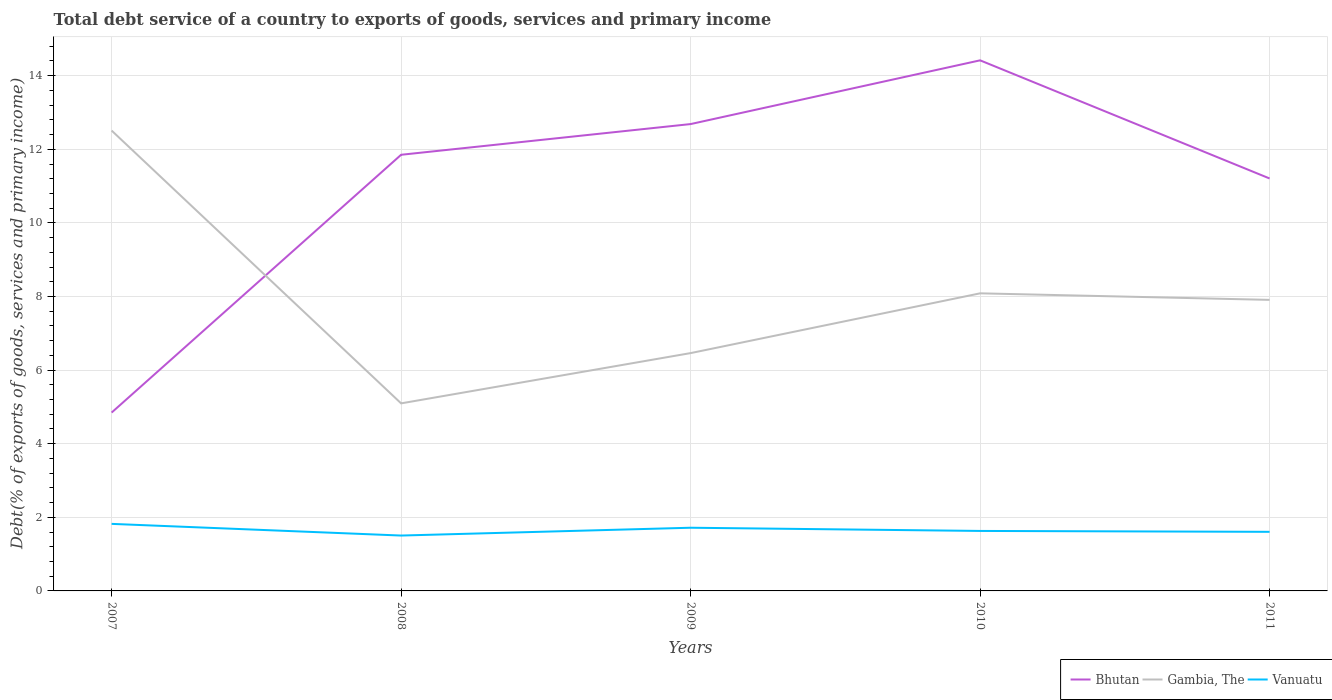How many different coloured lines are there?
Keep it short and to the point. 3. Across all years, what is the maximum total debt service in Gambia, The?
Your answer should be very brief. 5.1. In which year was the total debt service in Bhutan maximum?
Your answer should be very brief. 2007. What is the total total debt service in Bhutan in the graph?
Give a very brief answer. -7. What is the difference between the highest and the second highest total debt service in Gambia, The?
Your response must be concise. 7.41. What is the difference between the highest and the lowest total debt service in Gambia, The?
Make the answer very short. 2. Is the total debt service in Bhutan strictly greater than the total debt service in Gambia, The over the years?
Offer a very short reply. No. How many lines are there?
Provide a short and direct response. 3. How many years are there in the graph?
Provide a short and direct response. 5. Does the graph contain any zero values?
Offer a very short reply. No. Where does the legend appear in the graph?
Your answer should be compact. Bottom right. How many legend labels are there?
Provide a short and direct response. 3. What is the title of the graph?
Ensure brevity in your answer.  Total debt service of a country to exports of goods, services and primary income. What is the label or title of the Y-axis?
Your answer should be very brief. Debt(% of exports of goods, services and primary income). What is the Debt(% of exports of goods, services and primary income) of Bhutan in 2007?
Give a very brief answer. 4.85. What is the Debt(% of exports of goods, services and primary income) in Gambia, The in 2007?
Offer a terse response. 12.51. What is the Debt(% of exports of goods, services and primary income) in Vanuatu in 2007?
Provide a succinct answer. 1.82. What is the Debt(% of exports of goods, services and primary income) of Bhutan in 2008?
Your response must be concise. 11.85. What is the Debt(% of exports of goods, services and primary income) of Gambia, The in 2008?
Make the answer very short. 5.1. What is the Debt(% of exports of goods, services and primary income) of Vanuatu in 2008?
Provide a short and direct response. 1.5. What is the Debt(% of exports of goods, services and primary income) of Bhutan in 2009?
Offer a terse response. 12.68. What is the Debt(% of exports of goods, services and primary income) of Gambia, The in 2009?
Offer a terse response. 6.46. What is the Debt(% of exports of goods, services and primary income) of Vanuatu in 2009?
Your answer should be very brief. 1.72. What is the Debt(% of exports of goods, services and primary income) in Bhutan in 2010?
Give a very brief answer. 14.42. What is the Debt(% of exports of goods, services and primary income) of Gambia, The in 2010?
Ensure brevity in your answer.  8.09. What is the Debt(% of exports of goods, services and primary income) in Vanuatu in 2010?
Offer a very short reply. 1.63. What is the Debt(% of exports of goods, services and primary income) of Bhutan in 2011?
Give a very brief answer. 11.21. What is the Debt(% of exports of goods, services and primary income) in Gambia, The in 2011?
Make the answer very short. 7.91. What is the Debt(% of exports of goods, services and primary income) of Vanuatu in 2011?
Keep it short and to the point. 1.61. Across all years, what is the maximum Debt(% of exports of goods, services and primary income) of Bhutan?
Provide a succinct answer. 14.42. Across all years, what is the maximum Debt(% of exports of goods, services and primary income) of Gambia, The?
Offer a terse response. 12.51. Across all years, what is the maximum Debt(% of exports of goods, services and primary income) of Vanuatu?
Ensure brevity in your answer.  1.82. Across all years, what is the minimum Debt(% of exports of goods, services and primary income) in Bhutan?
Keep it short and to the point. 4.85. Across all years, what is the minimum Debt(% of exports of goods, services and primary income) in Gambia, The?
Your answer should be compact. 5.1. Across all years, what is the minimum Debt(% of exports of goods, services and primary income) in Vanuatu?
Make the answer very short. 1.5. What is the total Debt(% of exports of goods, services and primary income) in Bhutan in the graph?
Offer a terse response. 55.01. What is the total Debt(% of exports of goods, services and primary income) of Gambia, The in the graph?
Provide a succinct answer. 40.06. What is the total Debt(% of exports of goods, services and primary income) in Vanuatu in the graph?
Offer a very short reply. 8.28. What is the difference between the Debt(% of exports of goods, services and primary income) of Bhutan in 2007 and that in 2008?
Offer a very short reply. -7. What is the difference between the Debt(% of exports of goods, services and primary income) of Gambia, The in 2007 and that in 2008?
Provide a short and direct response. 7.41. What is the difference between the Debt(% of exports of goods, services and primary income) in Vanuatu in 2007 and that in 2008?
Your answer should be compact. 0.32. What is the difference between the Debt(% of exports of goods, services and primary income) of Bhutan in 2007 and that in 2009?
Give a very brief answer. -7.84. What is the difference between the Debt(% of exports of goods, services and primary income) in Gambia, The in 2007 and that in 2009?
Provide a succinct answer. 6.05. What is the difference between the Debt(% of exports of goods, services and primary income) of Vanuatu in 2007 and that in 2009?
Make the answer very short. 0.1. What is the difference between the Debt(% of exports of goods, services and primary income) in Bhutan in 2007 and that in 2010?
Give a very brief answer. -9.57. What is the difference between the Debt(% of exports of goods, services and primary income) of Gambia, The in 2007 and that in 2010?
Offer a very short reply. 4.42. What is the difference between the Debt(% of exports of goods, services and primary income) of Vanuatu in 2007 and that in 2010?
Give a very brief answer. 0.19. What is the difference between the Debt(% of exports of goods, services and primary income) of Bhutan in 2007 and that in 2011?
Keep it short and to the point. -6.36. What is the difference between the Debt(% of exports of goods, services and primary income) of Gambia, The in 2007 and that in 2011?
Offer a very short reply. 4.6. What is the difference between the Debt(% of exports of goods, services and primary income) of Vanuatu in 2007 and that in 2011?
Give a very brief answer. 0.22. What is the difference between the Debt(% of exports of goods, services and primary income) of Bhutan in 2008 and that in 2009?
Ensure brevity in your answer.  -0.83. What is the difference between the Debt(% of exports of goods, services and primary income) of Gambia, The in 2008 and that in 2009?
Offer a very short reply. -1.37. What is the difference between the Debt(% of exports of goods, services and primary income) of Vanuatu in 2008 and that in 2009?
Your answer should be very brief. -0.21. What is the difference between the Debt(% of exports of goods, services and primary income) in Bhutan in 2008 and that in 2010?
Provide a short and direct response. -2.57. What is the difference between the Debt(% of exports of goods, services and primary income) of Gambia, The in 2008 and that in 2010?
Your answer should be compact. -2.99. What is the difference between the Debt(% of exports of goods, services and primary income) in Vanuatu in 2008 and that in 2010?
Ensure brevity in your answer.  -0.13. What is the difference between the Debt(% of exports of goods, services and primary income) in Bhutan in 2008 and that in 2011?
Your answer should be compact. 0.64. What is the difference between the Debt(% of exports of goods, services and primary income) of Gambia, The in 2008 and that in 2011?
Make the answer very short. -2.81. What is the difference between the Debt(% of exports of goods, services and primary income) in Vanuatu in 2008 and that in 2011?
Your response must be concise. -0.1. What is the difference between the Debt(% of exports of goods, services and primary income) of Bhutan in 2009 and that in 2010?
Your response must be concise. -1.73. What is the difference between the Debt(% of exports of goods, services and primary income) in Gambia, The in 2009 and that in 2010?
Offer a very short reply. -1.62. What is the difference between the Debt(% of exports of goods, services and primary income) in Vanuatu in 2009 and that in 2010?
Your answer should be very brief. 0.09. What is the difference between the Debt(% of exports of goods, services and primary income) in Bhutan in 2009 and that in 2011?
Your answer should be compact. 1.48. What is the difference between the Debt(% of exports of goods, services and primary income) of Gambia, The in 2009 and that in 2011?
Offer a terse response. -1.45. What is the difference between the Debt(% of exports of goods, services and primary income) in Vanuatu in 2009 and that in 2011?
Offer a terse response. 0.11. What is the difference between the Debt(% of exports of goods, services and primary income) in Bhutan in 2010 and that in 2011?
Your answer should be very brief. 3.21. What is the difference between the Debt(% of exports of goods, services and primary income) in Gambia, The in 2010 and that in 2011?
Keep it short and to the point. 0.18. What is the difference between the Debt(% of exports of goods, services and primary income) of Vanuatu in 2010 and that in 2011?
Ensure brevity in your answer.  0.02. What is the difference between the Debt(% of exports of goods, services and primary income) in Bhutan in 2007 and the Debt(% of exports of goods, services and primary income) in Gambia, The in 2008?
Provide a short and direct response. -0.25. What is the difference between the Debt(% of exports of goods, services and primary income) in Bhutan in 2007 and the Debt(% of exports of goods, services and primary income) in Vanuatu in 2008?
Ensure brevity in your answer.  3.34. What is the difference between the Debt(% of exports of goods, services and primary income) in Gambia, The in 2007 and the Debt(% of exports of goods, services and primary income) in Vanuatu in 2008?
Keep it short and to the point. 11. What is the difference between the Debt(% of exports of goods, services and primary income) in Bhutan in 2007 and the Debt(% of exports of goods, services and primary income) in Gambia, The in 2009?
Offer a terse response. -1.62. What is the difference between the Debt(% of exports of goods, services and primary income) of Bhutan in 2007 and the Debt(% of exports of goods, services and primary income) of Vanuatu in 2009?
Your answer should be very brief. 3.13. What is the difference between the Debt(% of exports of goods, services and primary income) of Gambia, The in 2007 and the Debt(% of exports of goods, services and primary income) of Vanuatu in 2009?
Your answer should be compact. 10.79. What is the difference between the Debt(% of exports of goods, services and primary income) in Bhutan in 2007 and the Debt(% of exports of goods, services and primary income) in Gambia, The in 2010?
Your answer should be compact. -3.24. What is the difference between the Debt(% of exports of goods, services and primary income) of Bhutan in 2007 and the Debt(% of exports of goods, services and primary income) of Vanuatu in 2010?
Keep it short and to the point. 3.22. What is the difference between the Debt(% of exports of goods, services and primary income) in Gambia, The in 2007 and the Debt(% of exports of goods, services and primary income) in Vanuatu in 2010?
Your response must be concise. 10.88. What is the difference between the Debt(% of exports of goods, services and primary income) in Bhutan in 2007 and the Debt(% of exports of goods, services and primary income) in Gambia, The in 2011?
Your answer should be very brief. -3.06. What is the difference between the Debt(% of exports of goods, services and primary income) in Bhutan in 2007 and the Debt(% of exports of goods, services and primary income) in Vanuatu in 2011?
Your response must be concise. 3.24. What is the difference between the Debt(% of exports of goods, services and primary income) of Gambia, The in 2007 and the Debt(% of exports of goods, services and primary income) of Vanuatu in 2011?
Offer a terse response. 10.9. What is the difference between the Debt(% of exports of goods, services and primary income) in Bhutan in 2008 and the Debt(% of exports of goods, services and primary income) in Gambia, The in 2009?
Provide a succinct answer. 5.39. What is the difference between the Debt(% of exports of goods, services and primary income) of Bhutan in 2008 and the Debt(% of exports of goods, services and primary income) of Vanuatu in 2009?
Your response must be concise. 10.13. What is the difference between the Debt(% of exports of goods, services and primary income) of Gambia, The in 2008 and the Debt(% of exports of goods, services and primary income) of Vanuatu in 2009?
Ensure brevity in your answer.  3.38. What is the difference between the Debt(% of exports of goods, services and primary income) of Bhutan in 2008 and the Debt(% of exports of goods, services and primary income) of Gambia, The in 2010?
Ensure brevity in your answer.  3.76. What is the difference between the Debt(% of exports of goods, services and primary income) in Bhutan in 2008 and the Debt(% of exports of goods, services and primary income) in Vanuatu in 2010?
Your answer should be very brief. 10.22. What is the difference between the Debt(% of exports of goods, services and primary income) in Gambia, The in 2008 and the Debt(% of exports of goods, services and primary income) in Vanuatu in 2010?
Your response must be concise. 3.47. What is the difference between the Debt(% of exports of goods, services and primary income) in Bhutan in 2008 and the Debt(% of exports of goods, services and primary income) in Gambia, The in 2011?
Give a very brief answer. 3.94. What is the difference between the Debt(% of exports of goods, services and primary income) in Bhutan in 2008 and the Debt(% of exports of goods, services and primary income) in Vanuatu in 2011?
Offer a very short reply. 10.24. What is the difference between the Debt(% of exports of goods, services and primary income) of Gambia, The in 2008 and the Debt(% of exports of goods, services and primary income) of Vanuatu in 2011?
Keep it short and to the point. 3.49. What is the difference between the Debt(% of exports of goods, services and primary income) of Bhutan in 2009 and the Debt(% of exports of goods, services and primary income) of Gambia, The in 2010?
Offer a very short reply. 4.6. What is the difference between the Debt(% of exports of goods, services and primary income) in Bhutan in 2009 and the Debt(% of exports of goods, services and primary income) in Vanuatu in 2010?
Keep it short and to the point. 11.05. What is the difference between the Debt(% of exports of goods, services and primary income) in Gambia, The in 2009 and the Debt(% of exports of goods, services and primary income) in Vanuatu in 2010?
Ensure brevity in your answer.  4.83. What is the difference between the Debt(% of exports of goods, services and primary income) of Bhutan in 2009 and the Debt(% of exports of goods, services and primary income) of Gambia, The in 2011?
Make the answer very short. 4.78. What is the difference between the Debt(% of exports of goods, services and primary income) of Bhutan in 2009 and the Debt(% of exports of goods, services and primary income) of Vanuatu in 2011?
Provide a short and direct response. 11.08. What is the difference between the Debt(% of exports of goods, services and primary income) of Gambia, The in 2009 and the Debt(% of exports of goods, services and primary income) of Vanuatu in 2011?
Offer a terse response. 4.86. What is the difference between the Debt(% of exports of goods, services and primary income) in Bhutan in 2010 and the Debt(% of exports of goods, services and primary income) in Gambia, The in 2011?
Provide a succinct answer. 6.51. What is the difference between the Debt(% of exports of goods, services and primary income) in Bhutan in 2010 and the Debt(% of exports of goods, services and primary income) in Vanuatu in 2011?
Provide a succinct answer. 12.81. What is the difference between the Debt(% of exports of goods, services and primary income) of Gambia, The in 2010 and the Debt(% of exports of goods, services and primary income) of Vanuatu in 2011?
Keep it short and to the point. 6.48. What is the average Debt(% of exports of goods, services and primary income) of Bhutan per year?
Provide a succinct answer. 11. What is the average Debt(% of exports of goods, services and primary income) of Gambia, The per year?
Make the answer very short. 8.01. What is the average Debt(% of exports of goods, services and primary income) in Vanuatu per year?
Give a very brief answer. 1.66. In the year 2007, what is the difference between the Debt(% of exports of goods, services and primary income) in Bhutan and Debt(% of exports of goods, services and primary income) in Gambia, The?
Your answer should be compact. -7.66. In the year 2007, what is the difference between the Debt(% of exports of goods, services and primary income) of Bhutan and Debt(% of exports of goods, services and primary income) of Vanuatu?
Give a very brief answer. 3.02. In the year 2007, what is the difference between the Debt(% of exports of goods, services and primary income) of Gambia, The and Debt(% of exports of goods, services and primary income) of Vanuatu?
Your answer should be very brief. 10.69. In the year 2008, what is the difference between the Debt(% of exports of goods, services and primary income) of Bhutan and Debt(% of exports of goods, services and primary income) of Gambia, The?
Your answer should be compact. 6.75. In the year 2008, what is the difference between the Debt(% of exports of goods, services and primary income) in Bhutan and Debt(% of exports of goods, services and primary income) in Vanuatu?
Your response must be concise. 10.35. In the year 2008, what is the difference between the Debt(% of exports of goods, services and primary income) of Gambia, The and Debt(% of exports of goods, services and primary income) of Vanuatu?
Keep it short and to the point. 3.59. In the year 2009, what is the difference between the Debt(% of exports of goods, services and primary income) in Bhutan and Debt(% of exports of goods, services and primary income) in Gambia, The?
Provide a short and direct response. 6.22. In the year 2009, what is the difference between the Debt(% of exports of goods, services and primary income) of Bhutan and Debt(% of exports of goods, services and primary income) of Vanuatu?
Make the answer very short. 10.97. In the year 2009, what is the difference between the Debt(% of exports of goods, services and primary income) in Gambia, The and Debt(% of exports of goods, services and primary income) in Vanuatu?
Give a very brief answer. 4.75. In the year 2010, what is the difference between the Debt(% of exports of goods, services and primary income) in Bhutan and Debt(% of exports of goods, services and primary income) in Gambia, The?
Offer a very short reply. 6.33. In the year 2010, what is the difference between the Debt(% of exports of goods, services and primary income) of Bhutan and Debt(% of exports of goods, services and primary income) of Vanuatu?
Your answer should be very brief. 12.79. In the year 2010, what is the difference between the Debt(% of exports of goods, services and primary income) in Gambia, The and Debt(% of exports of goods, services and primary income) in Vanuatu?
Offer a terse response. 6.46. In the year 2011, what is the difference between the Debt(% of exports of goods, services and primary income) in Bhutan and Debt(% of exports of goods, services and primary income) in Gambia, The?
Your answer should be compact. 3.3. In the year 2011, what is the difference between the Debt(% of exports of goods, services and primary income) of Bhutan and Debt(% of exports of goods, services and primary income) of Vanuatu?
Offer a terse response. 9.6. In the year 2011, what is the difference between the Debt(% of exports of goods, services and primary income) of Gambia, The and Debt(% of exports of goods, services and primary income) of Vanuatu?
Keep it short and to the point. 6.3. What is the ratio of the Debt(% of exports of goods, services and primary income) of Bhutan in 2007 to that in 2008?
Offer a terse response. 0.41. What is the ratio of the Debt(% of exports of goods, services and primary income) in Gambia, The in 2007 to that in 2008?
Offer a terse response. 2.45. What is the ratio of the Debt(% of exports of goods, services and primary income) in Vanuatu in 2007 to that in 2008?
Ensure brevity in your answer.  1.21. What is the ratio of the Debt(% of exports of goods, services and primary income) of Bhutan in 2007 to that in 2009?
Make the answer very short. 0.38. What is the ratio of the Debt(% of exports of goods, services and primary income) in Gambia, The in 2007 to that in 2009?
Provide a short and direct response. 1.94. What is the ratio of the Debt(% of exports of goods, services and primary income) of Vanuatu in 2007 to that in 2009?
Make the answer very short. 1.06. What is the ratio of the Debt(% of exports of goods, services and primary income) in Bhutan in 2007 to that in 2010?
Provide a short and direct response. 0.34. What is the ratio of the Debt(% of exports of goods, services and primary income) of Gambia, The in 2007 to that in 2010?
Your answer should be very brief. 1.55. What is the ratio of the Debt(% of exports of goods, services and primary income) of Vanuatu in 2007 to that in 2010?
Your answer should be very brief. 1.12. What is the ratio of the Debt(% of exports of goods, services and primary income) in Bhutan in 2007 to that in 2011?
Keep it short and to the point. 0.43. What is the ratio of the Debt(% of exports of goods, services and primary income) of Gambia, The in 2007 to that in 2011?
Ensure brevity in your answer.  1.58. What is the ratio of the Debt(% of exports of goods, services and primary income) of Vanuatu in 2007 to that in 2011?
Offer a terse response. 1.13. What is the ratio of the Debt(% of exports of goods, services and primary income) in Bhutan in 2008 to that in 2009?
Your answer should be very brief. 0.93. What is the ratio of the Debt(% of exports of goods, services and primary income) in Gambia, The in 2008 to that in 2009?
Give a very brief answer. 0.79. What is the ratio of the Debt(% of exports of goods, services and primary income) in Vanuatu in 2008 to that in 2009?
Provide a short and direct response. 0.88. What is the ratio of the Debt(% of exports of goods, services and primary income) in Bhutan in 2008 to that in 2010?
Offer a very short reply. 0.82. What is the ratio of the Debt(% of exports of goods, services and primary income) in Gambia, The in 2008 to that in 2010?
Keep it short and to the point. 0.63. What is the ratio of the Debt(% of exports of goods, services and primary income) of Vanuatu in 2008 to that in 2010?
Your response must be concise. 0.92. What is the ratio of the Debt(% of exports of goods, services and primary income) of Bhutan in 2008 to that in 2011?
Ensure brevity in your answer.  1.06. What is the ratio of the Debt(% of exports of goods, services and primary income) in Gambia, The in 2008 to that in 2011?
Keep it short and to the point. 0.64. What is the ratio of the Debt(% of exports of goods, services and primary income) of Vanuatu in 2008 to that in 2011?
Provide a short and direct response. 0.94. What is the ratio of the Debt(% of exports of goods, services and primary income) in Bhutan in 2009 to that in 2010?
Offer a terse response. 0.88. What is the ratio of the Debt(% of exports of goods, services and primary income) in Gambia, The in 2009 to that in 2010?
Your response must be concise. 0.8. What is the ratio of the Debt(% of exports of goods, services and primary income) in Vanuatu in 2009 to that in 2010?
Your answer should be very brief. 1.05. What is the ratio of the Debt(% of exports of goods, services and primary income) of Bhutan in 2009 to that in 2011?
Offer a terse response. 1.13. What is the ratio of the Debt(% of exports of goods, services and primary income) of Gambia, The in 2009 to that in 2011?
Keep it short and to the point. 0.82. What is the ratio of the Debt(% of exports of goods, services and primary income) of Vanuatu in 2009 to that in 2011?
Ensure brevity in your answer.  1.07. What is the ratio of the Debt(% of exports of goods, services and primary income) of Bhutan in 2010 to that in 2011?
Offer a very short reply. 1.29. What is the ratio of the Debt(% of exports of goods, services and primary income) of Gambia, The in 2010 to that in 2011?
Ensure brevity in your answer.  1.02. What is the ratio of the Debt(% of exports of goods, services and primary income) of Vanuatu in 2010 to that in 2011?
Your answer should be compact. 1.02. What is the difference between the highest and the second highest Debt(% of exports of goods, services and primary income) of Bhutan?
Provide a short and direct response. 1.73. What is the difference between the highest and the second highest Debt(% of exports of goods, services and primary income) of Gambia, The?
Offer a terse response. 4.42. What is the difference between the highest and the second highest Debt(% of exports of goods, services and primary income) of Vanuatu?
Your response must be concise. 0.1. What is the difference between the highest and the lowest Debt(% of exports of goods, services and primary income) in Bhutan?
Make the answer very short. 9.57. What is the difference between the highest and the lowest Debt(% of exports of goods, services and primary income) of Gambia, The?
Make the answer very short. 7.41. What is the difference between the highest and the lowest Debt(% of exports of goods, services and primary income) in Vanuatu?
Provide a succinct answer. 0.32. 